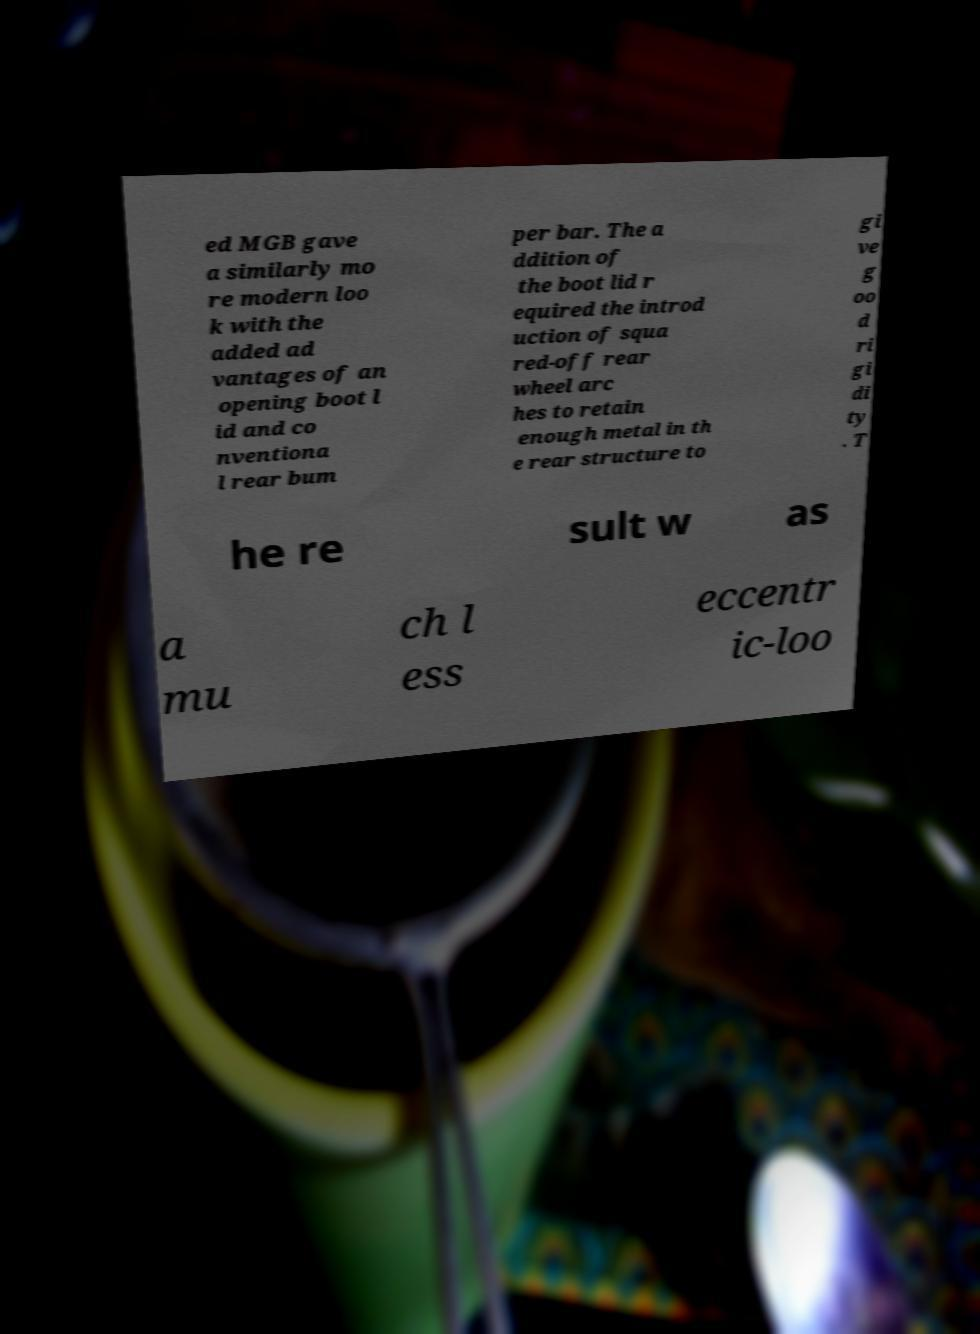For documentation purposes, I need the text within this image transcribed. Could you provide that? ed MGB gave a similarly mo re modern loo k with the added ad vantages of an opening boot l id and co nventiona l rear bum per bar. The a ddition of the boot lid r equired the introd uction of squa red-off rear wheel arc hes to retain enough metal in th e rear structure to gi ve g oo d ri gi di ty . T he re sult w as a mu ch l ess eccentr ic-loo 